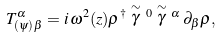Convert formula to latex. <formula><loc_0><loc_0><loc_500><loc_500>T ^ { \alpha } _ { ( \psi ) \, \beta } = i \, \omega ^ { 2 } ( z ) \rho ^ { \dag } \stackrel { \sim } { \gamma } \, ^ { 0 } \stackrel { \sim } { \gamma } \, ^ { \alpha } \, \partial _ { \beta } \rho ,</formula> 